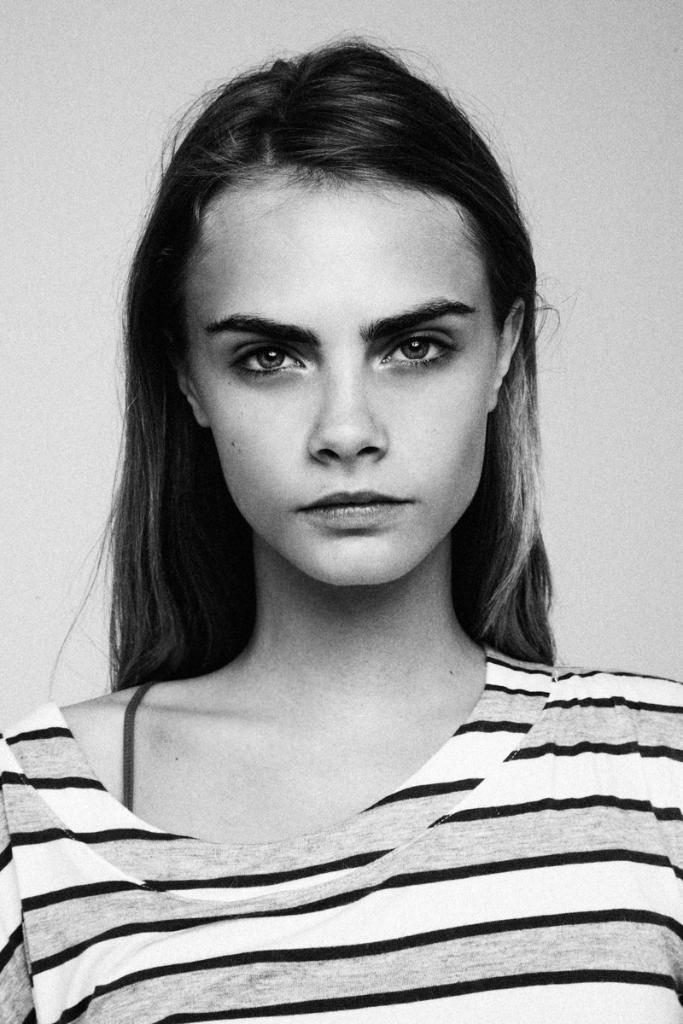Who is present in the image? There is a woman in the image. What is the color scheme of the image? The image is black and white in color. What type of rat can be seen interacting with the woman in the image? There is no rat present in the image; it only features a woman. How does the cub contribute to the scene in the image? There is no cub present in the image; it only features a woman. 